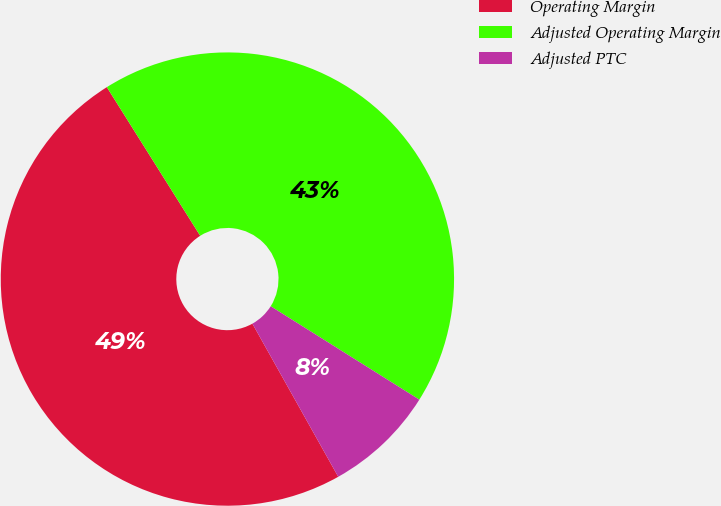Convert chart to OTSL. <chart><loc_0><loc_0><loc_500><loc_500><pie_chart><fcel>Operating Margin<fcel>Adjusted Operating Margin<fcel>Adjusted PTC<nl><fcel>49.21%<fcel>42.86%<fcel>7.94%<nl></chart> 